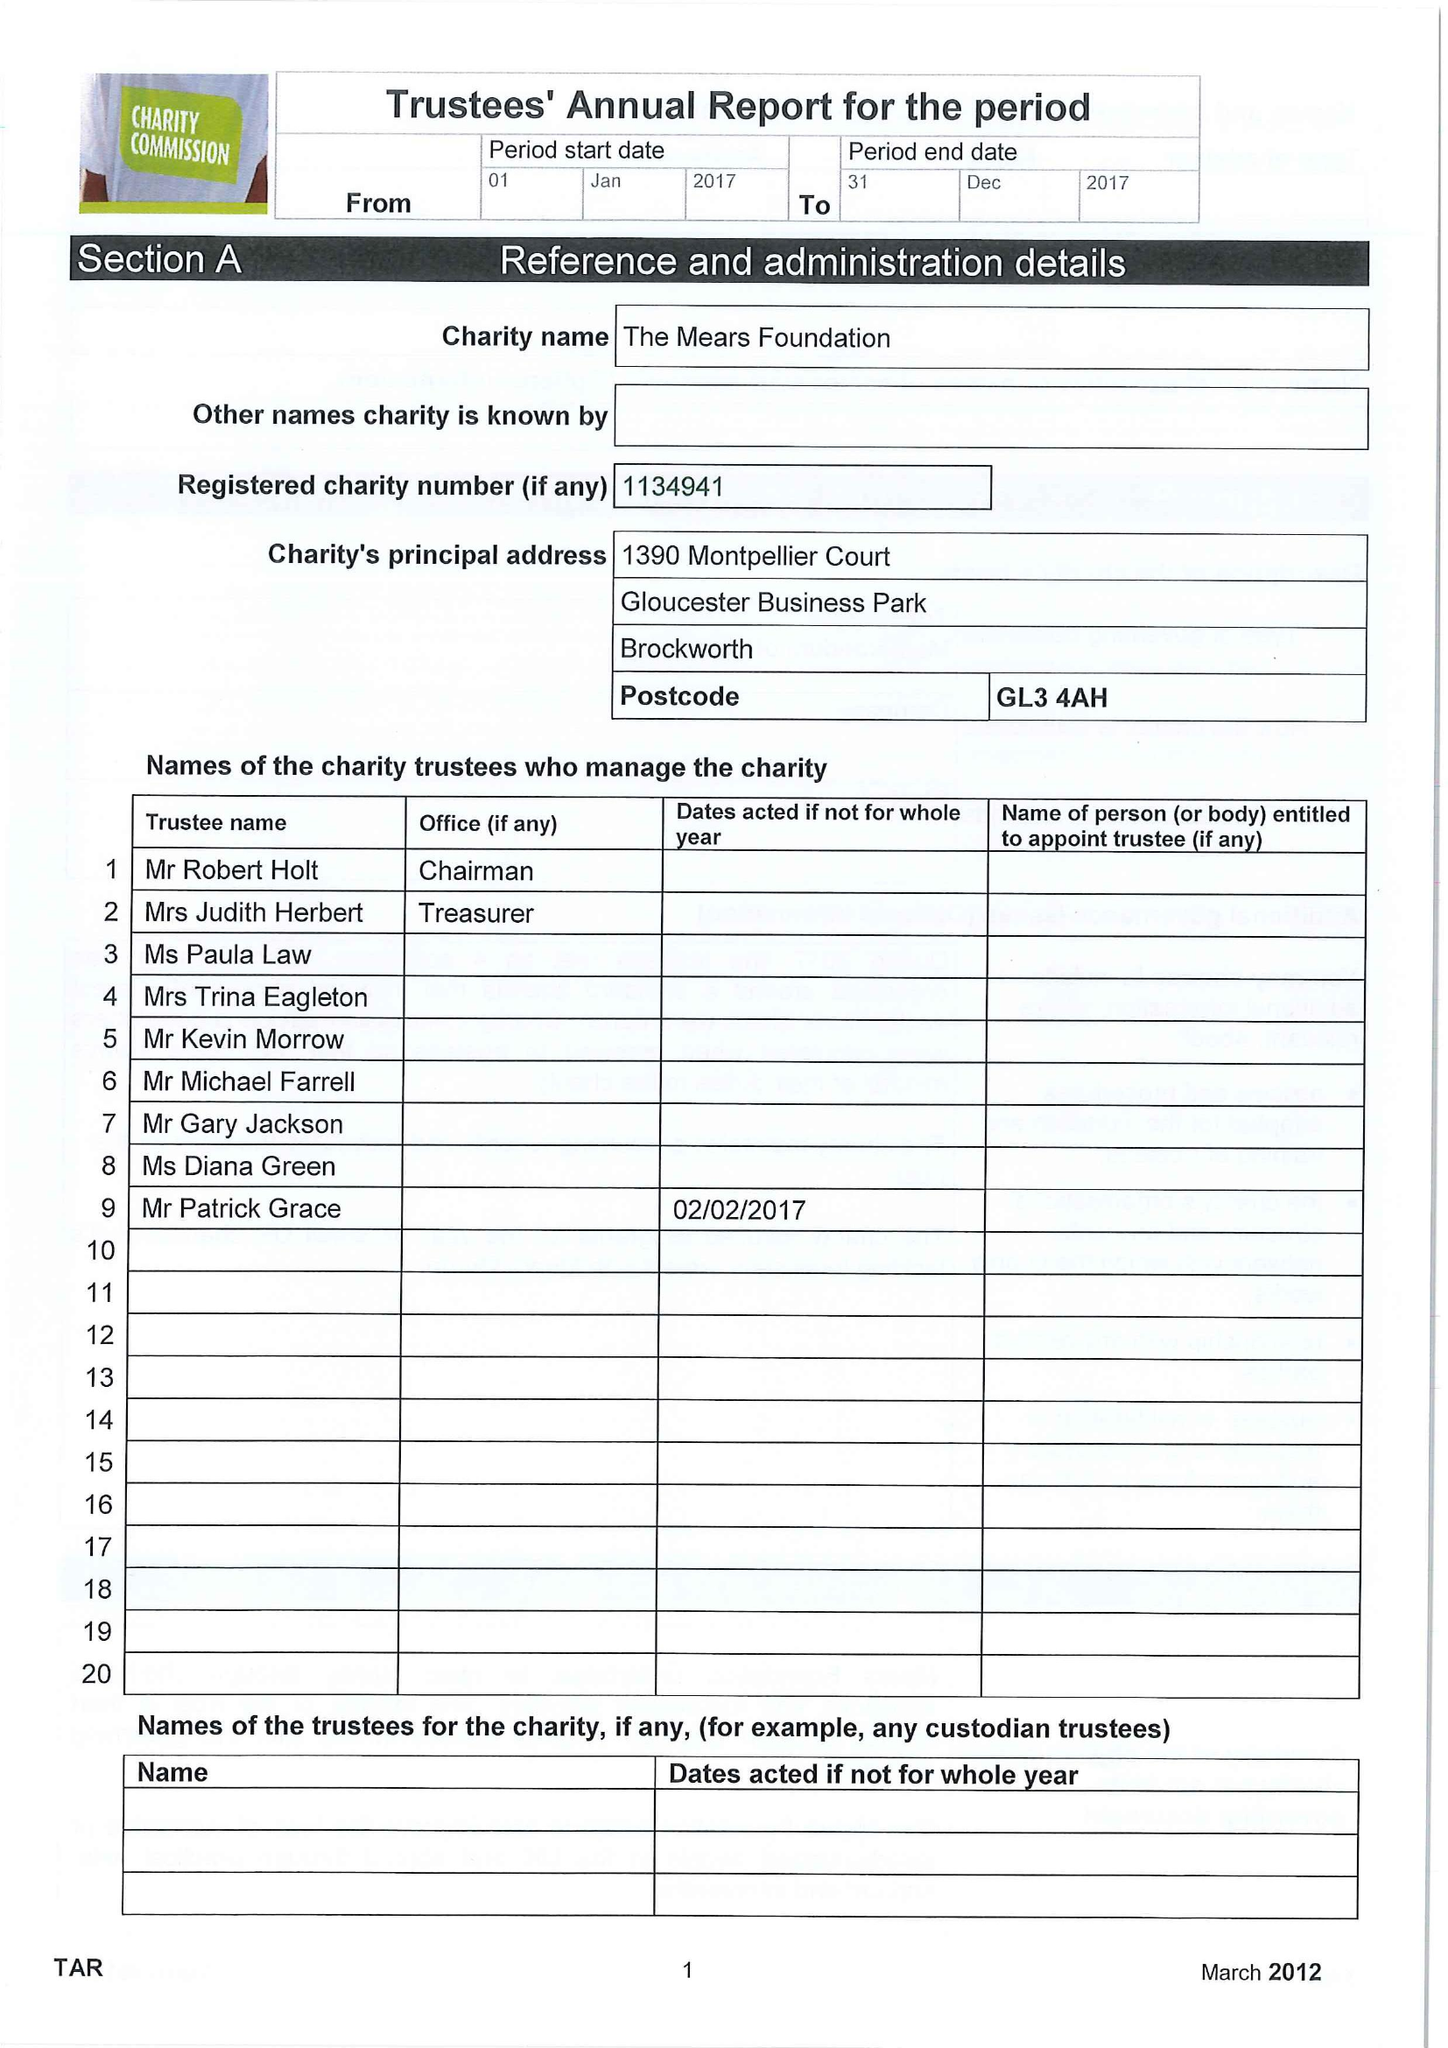What is the value for the report_date?
Answer the question using a single word or phrase. 2017-12-31 